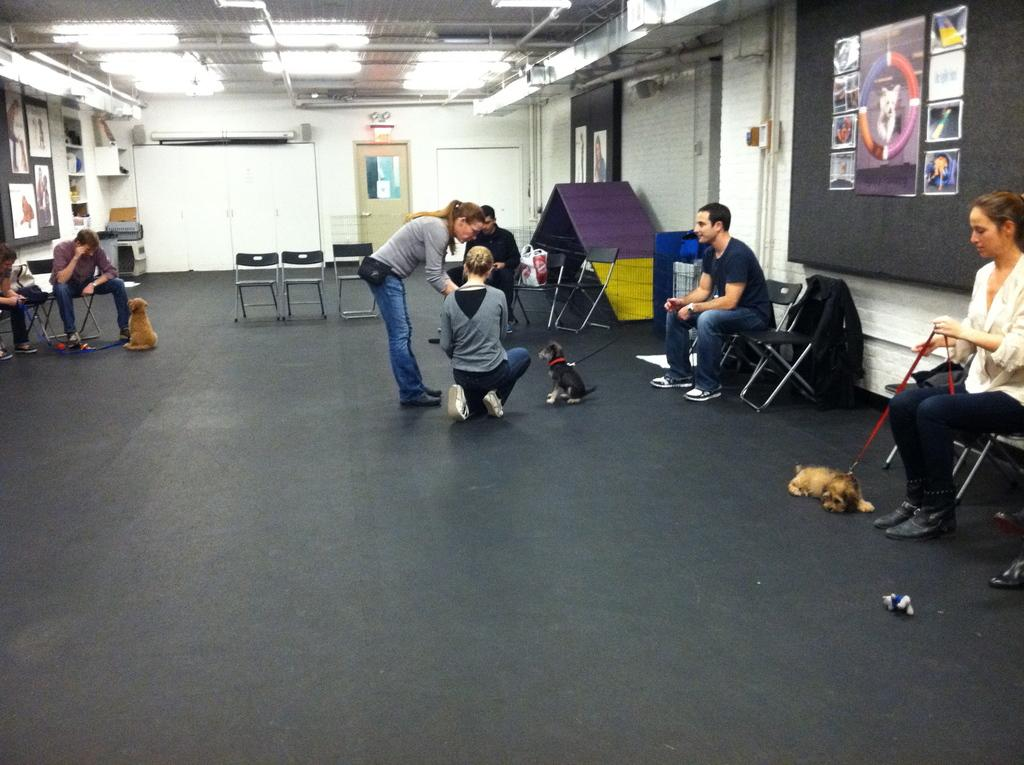How many people are sitting on chairs in the image? There are five people sitting on chairs in the image. What other animals, besides dogs, can be seen in the image? There are no other animals besides the three dogs in the image. Where are two people located in the image? Two people are on the floor in the image. What type of decorations are present in the image? There are posters in the image. What is one architectural feature visible in the image? There is a door in the image. What type of lighting is present in the image? There are lights in the image. What type of clothing is visible in the image? A jacket is visible in the image. What type of structure surrounds the people and dogs in the image? There are walls in the image. What type of plumbing feature is present in the image? Pipes are present in the image. How many matches are being used by the people in the image? There is no mention of matches in the image, so we cannot determine if any are being used. Can you see any mice in the image? There are no mice present in the image. What type of heart-related object can be seen in the image? There is no heart-related object present in the image. 